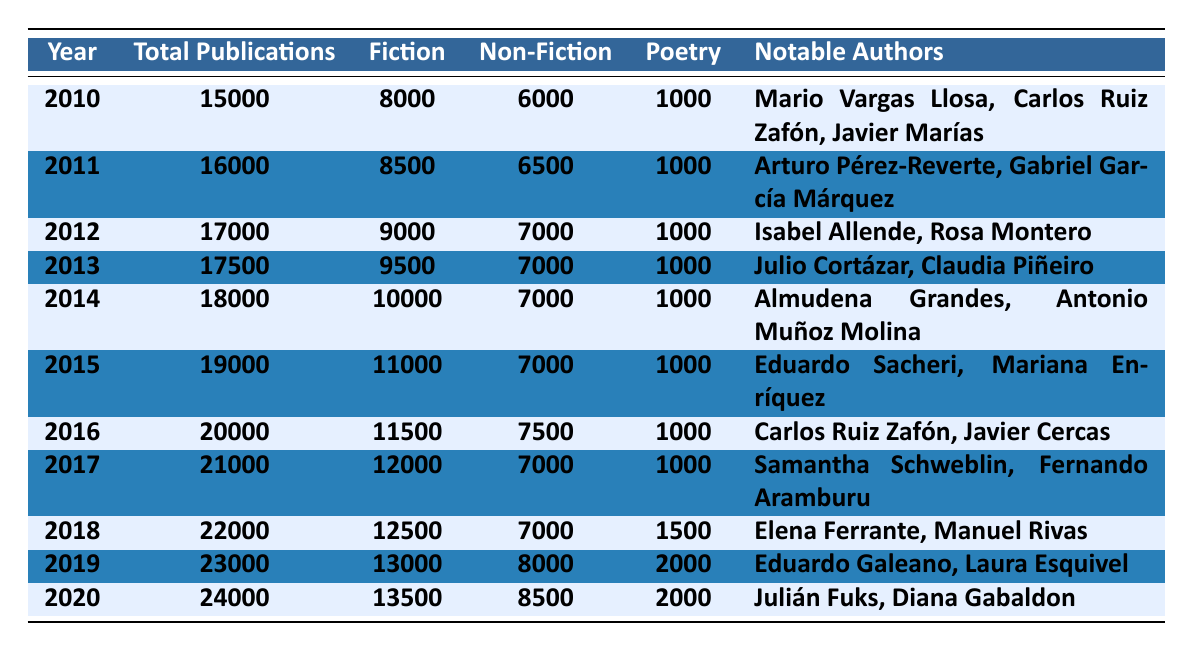What was the total number of publications in 2015? The total number of publications in 2015 is listed directly in the table, which states that the number was 19000.
Answer: 19000 Which year had the highest number of fiction publications? By examining the "Fiction" column, we see that 2020 had the highest number at 13500.
Answer: 2020 Is it true that the number of poetry publications remained the same from 2010 to 2015? Checking the poetry values in the table, the number is 1000 for 2010, 2011, 2012, 2013, 2014, and 2015, confirming it stayed the same.
Answer: Yes What is the total number of non-fiction publications from 2016 to 2020? The non-fiction publications for those years are: 7500 (2016) + 7000 (2017) + 7000 (2018) + 8000 (2019) + 8500 (2020) = 39500.
Answer: 39500 In which year did the number of total publications increase by the largest amount compared to the previous year? By looking at the total publications per year, we find the largest increase was from 2019 (23000) to 2020 (24000), which is an increase of 1000.
Answer: 2019 to 2020 What was the average number of poetry publications from 2010 to 2016? The poetry publications for those years are all 1000 except for 2018, which is 1500. With the values of 1000 (for 2010-2016) we have 7 times 1000 = 7000. To find the average: 7000 / 7 = 1000.
Answer: 1000 How many more fiction publications were there in 2020 than in 2010? In 2020, the number of fiction publications was 13500, and in 2010 it was 8000. The difference is 13500 - 8000 = 5500.
Answer: 5500 Which year had the least number of total publications in this data range? By examining the "Total Publications" row, it's clear that 2010 had the fewest at 15000.
Answer: 2010 What percentage of the total publications in 2019 were fiction? The total publications in 2019 were 23000 and fiction publications were 13000. To find the percentage: (13000 / 23000) * 100 = approximately 56.52%.
Answer: 56.52% Which notable author appeared in the most recent year listed in the table? The most recent year in the data is 2020, and the notable authors for that year are Julián Fuks and Diana Gabaldon, meaning they appeared there.
Answer: Julián Fuks, Diana Gabaldon 